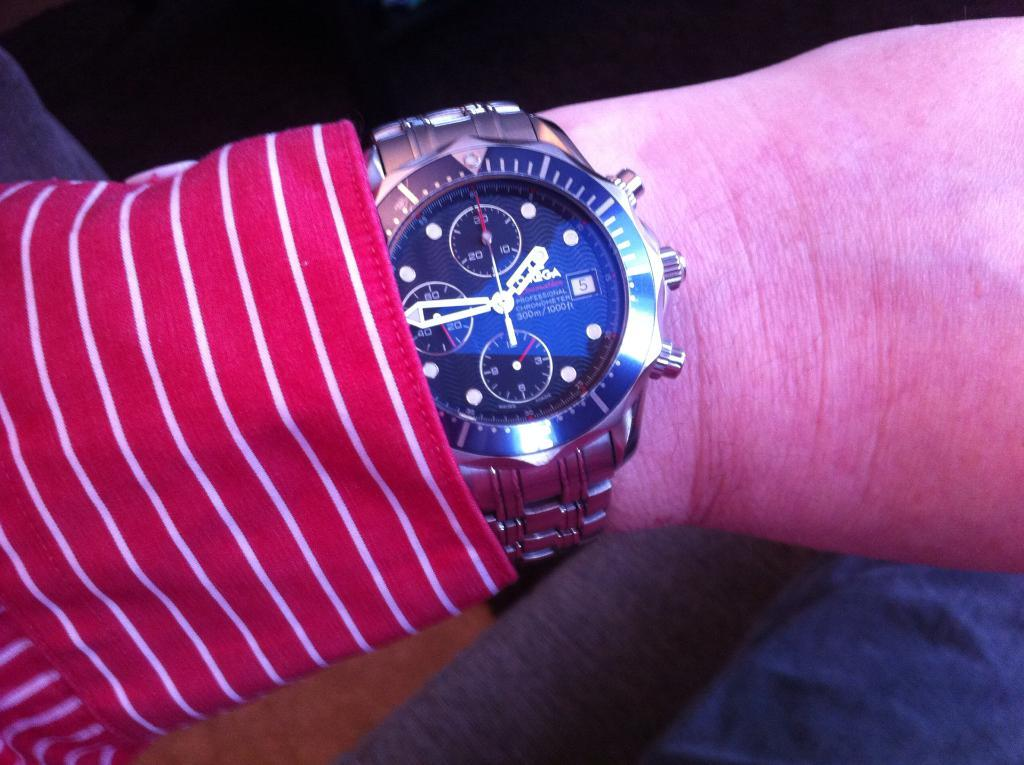Provide a one-sentence caption for the provided image. A person in a red shirt shows a watch that is waterproof down to 300 meters. 